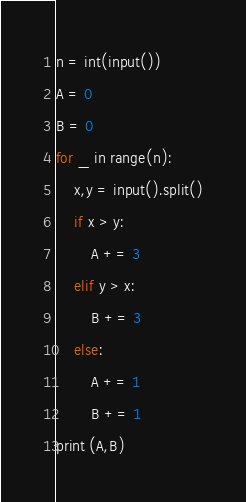<code> <loc_0><loc_0><loc_500><loc_500><_Python_>n = int(input())
A = 0
B = 0
for _ in range(n):
    x,y = input().split()
    if x > y:
        A += 3
    elif y > x:
        B += 3
    else:
        A += 1
        B += 1
print (A,B)

</code> 